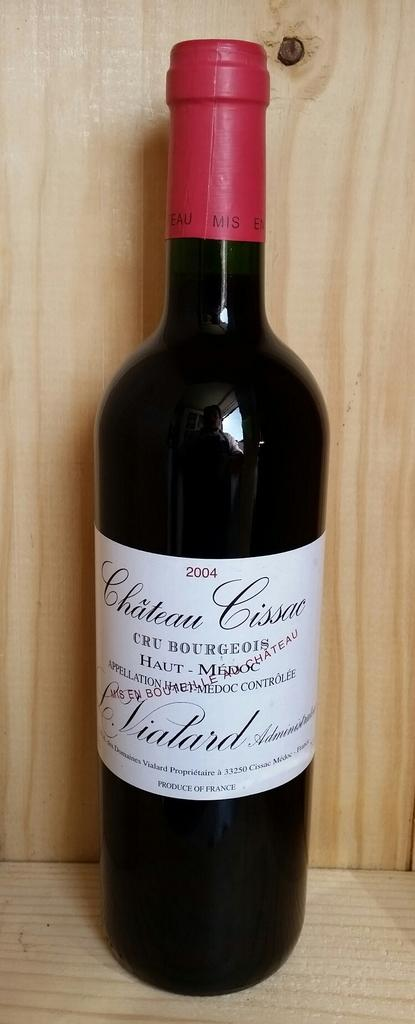<image>
Present a compact description of the photo's key features. A 2004 Chateau Cissac Cru Bourgeois bottle of wine. 